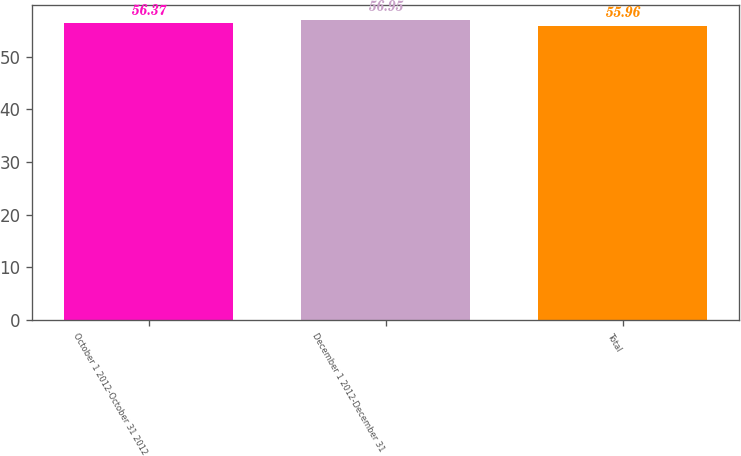Convert chart to OTSL. <chart><loc_0><loc_0><loc_500><loc_500><bar_chart><fcel>October 1 2012-October 31 2012<fcel>December 1 2012-December 31<fcel>Total<nl><fcel>56.37<fcel>56.95<fcel>55.96<nl></chart> 